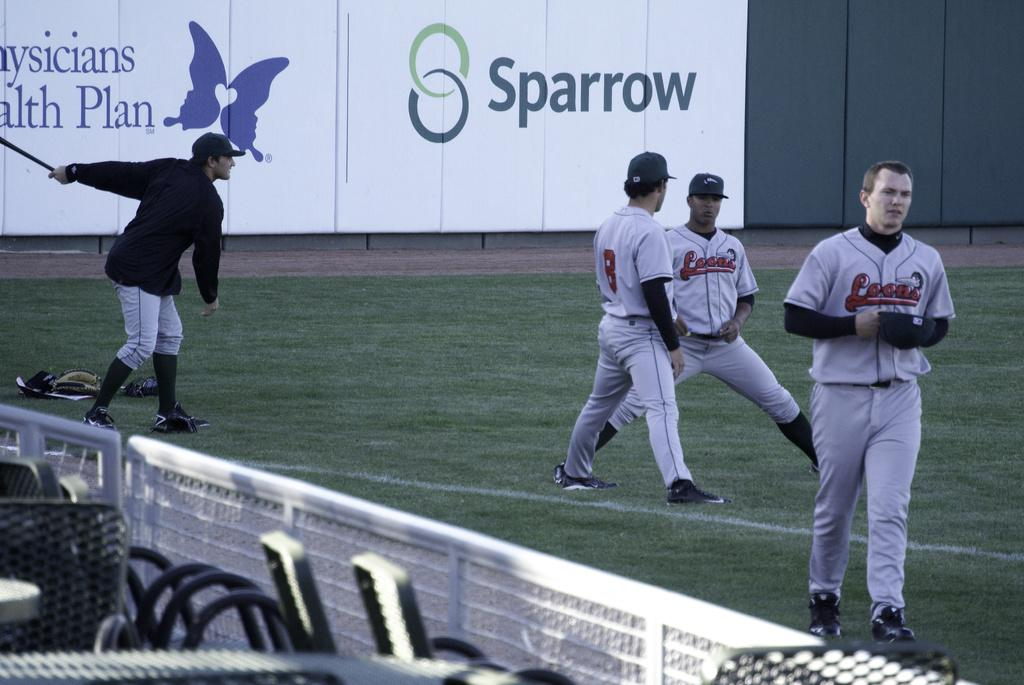<image>
Write a terse but informative summary of the picture. Loons is the name of the team shown on these player's jerseys. 